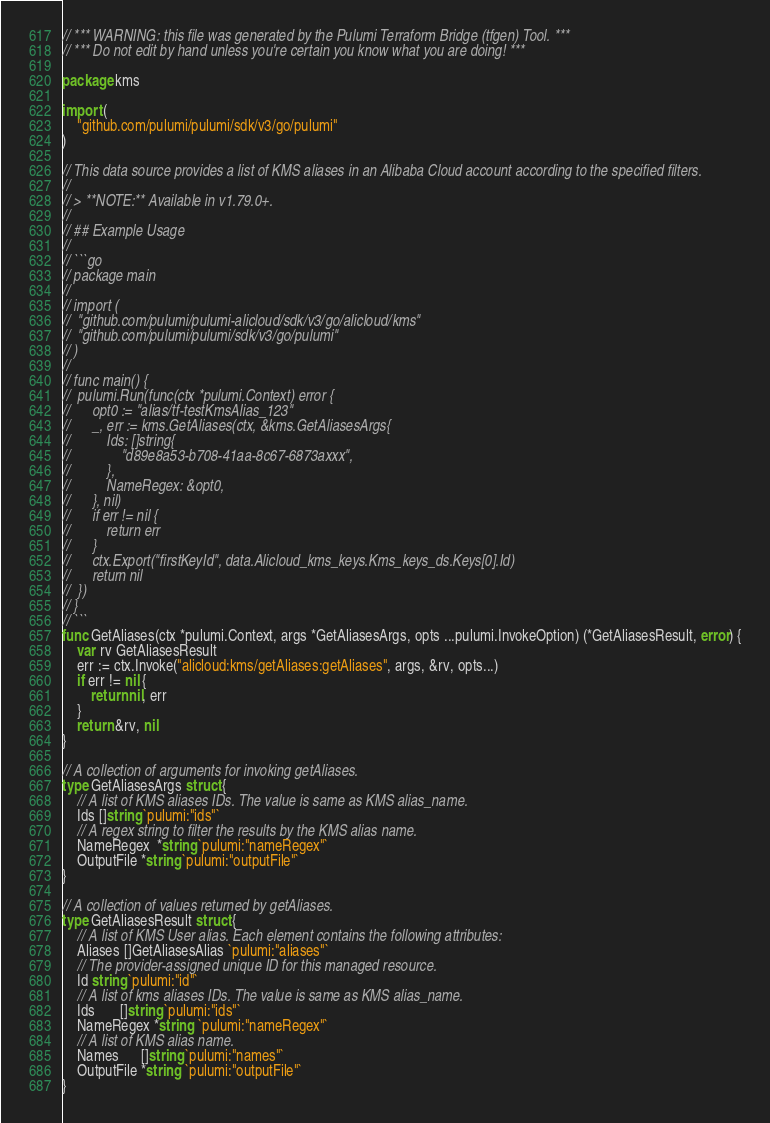<code> <loc_0><loc_0><loc_500><loc_500><_Go_>// *** WARNING: this file was generated by the Pulumi Terraform Bridge (tfgen) Tool. ***
// *** Do not edit by hand unless you're certain you know what you are doing! ***

package kms

import (
	"github.com/pulumi/pulumi/sdk/v3/go/pulumi"
)

// This data source provides a list of KMS aliases in an Alibaba Cloud account according to the specified filters.
//
// > **NOTE:** Available in v1.79.0+.
//
// ## Example Usage
//
// ```go
// package main
//
// import (
// 	"github.com/pulumi/pulumi-alicloud/sdk/v3/go/alicloud/kms"
// 	"github.com/pulumi/pulumi/sdk/v3/go/pulumi"
// )
//
// func main() {
// 	pulumi.Run(func(ctx *pulumi.Context) error {
// 		opt0 := "alias/tf-testKmsAlias_123"
// 		_, err := kms.GetAliases(ctx, &kms.GetAliasesArgs{
// 			Ids: []string{
// 				"d89e8a53-b708-41aa-8c67-6873axxx",
// 			},
// 			NameRegex: &opt0,
// 		}, nil)
// 		if err != nil {
// 			return err
// 		}
// 		ctx.Export("firstKeyId", data.Alicloud_kms_keys.Kms_keys_ds.Keys[0].Id)
// 		return nil
// 	})
// }
// ```
func GetAliases(ctx *pulumi.Context, args *GetAliasesArgs, opts ...pulumi.InvokeOption) (*GetAliasesResult, error) {
	var rv GetAliasesResult
	err := ctx.Invoke("alicloud:kms/getAliases:getAliases", args, &rv, opts...)
	if err != nil {
		return nil, err
	}
	return &rv, nil
}

// A collection of arguments for invoking getAliases.
type GetAliasesArgs struct {
	// A list of KMS aliases IDs. The value is same as KMS alias_name.
	Ids []string `pulumi:"ids"`
	// A regex string to filter the results by the KMS alias name.
	NameRegex  *string `pulumi:"nameRegex"`
	OutputFile *string `pulumi:"outputFile"`
}

// A collection of values returned by getAliases.
type GetAliasesResult struct {
	// A list of KMS User alias. Each element contains the following attributes:
	Aliases []GetAliasesAlias `pulumi:"aliases"`
	// The provider-assigned unique ID for this managed resource.
	Id string `pulumi:"id"`
	// A list of kms aliases IDs. The value is same as KMS alias_name.
	Ids       []string `pulumi:"ids"`
	NameRegex *string  `pulumi:"nameRegex"`
	// A list of KMS alias name.
	Names      []string `pulumi:"names"`
	OutputFile *string  `pulumi:"outputFile"`
}
</code> 